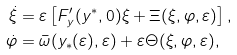<formula> <loc_0><loc_0><loc_500><loc_500>\dot { \xi } & = \varepsilon \left [ F _ { y } ^ { \prime } ( y ^ { \ast } , 0 ) \xi + \Xi ( \xi , \varphi , \varepsilon ) \right ] , \\ \dot { \varphi } & = \bar { \omega } ( y _ { \ast } ( \varepsilon ) , \varepsilon ) + \varepsilon \Theta ( \xi , \varphi , \varepsilon ) ,</formula> 